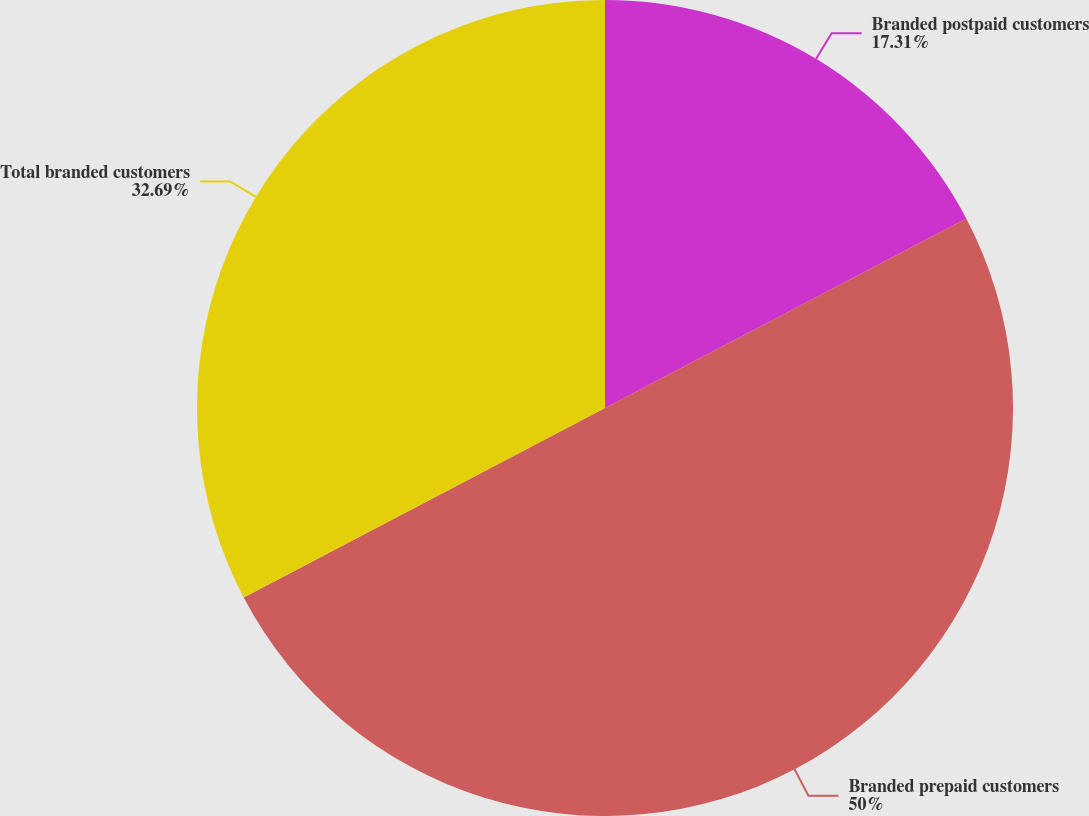<chart> <loc_0><loc_0><loc_500><loc_500><pie_chart><fcel>Branded postpaid customers<fcel>Branded prepaid customers<fcel>Total branded customers<nl><fcel>17.31%<fcel>50.0%<fcel>32.69%<nl></chart> 